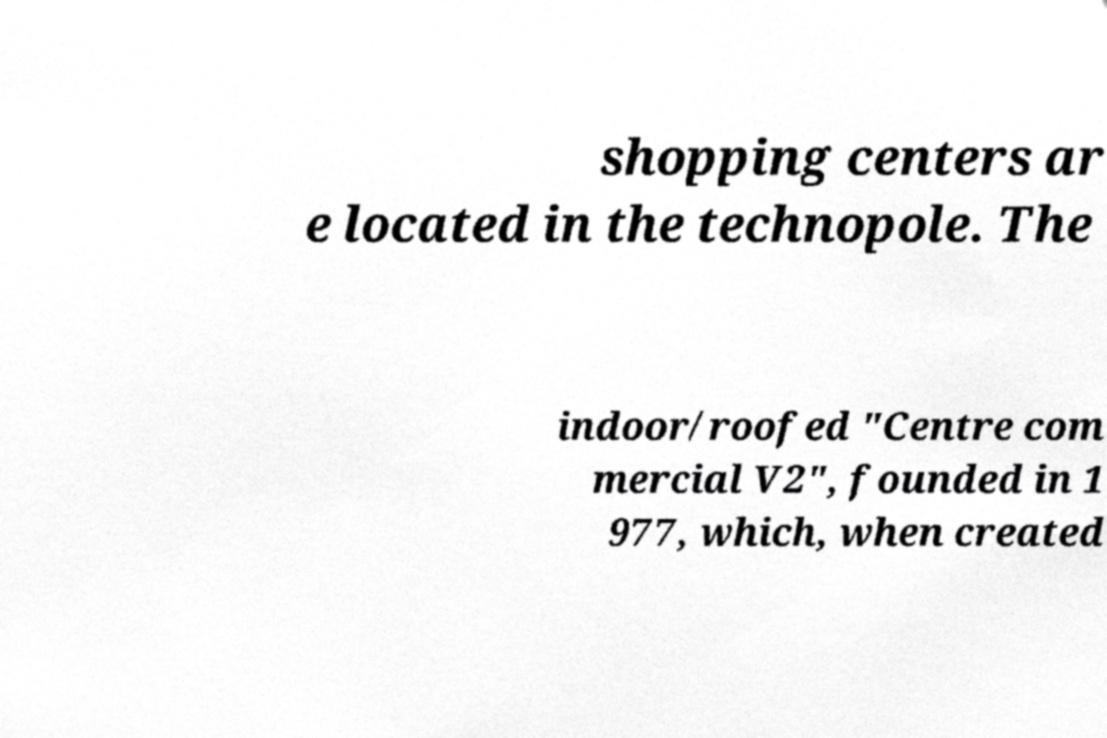Can you read and provide the text displayed in the image?This photo seems to have some interesting text. Can you extract and type it out for me? shopping centers ar e located in the technopole. The indoor/roofed "Centre com mercial V2", founded in 1 977, which, when created 